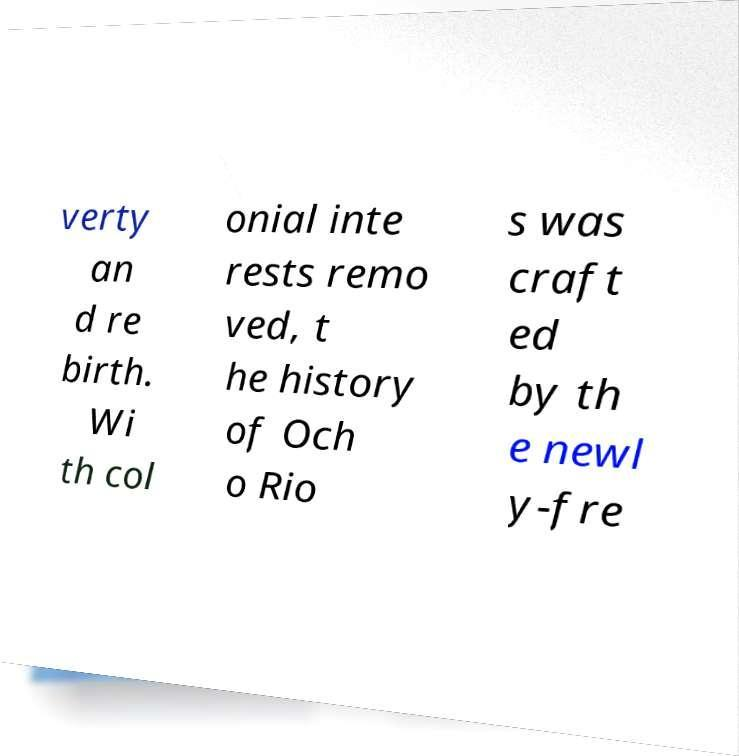For documentation purposes, I need the text within this image transcribed. Could you provide that? verty an d re birth. Wi th col onial inte rests remo ved, t he history of Och o Rio s was craft ed by th e newl y-fre 